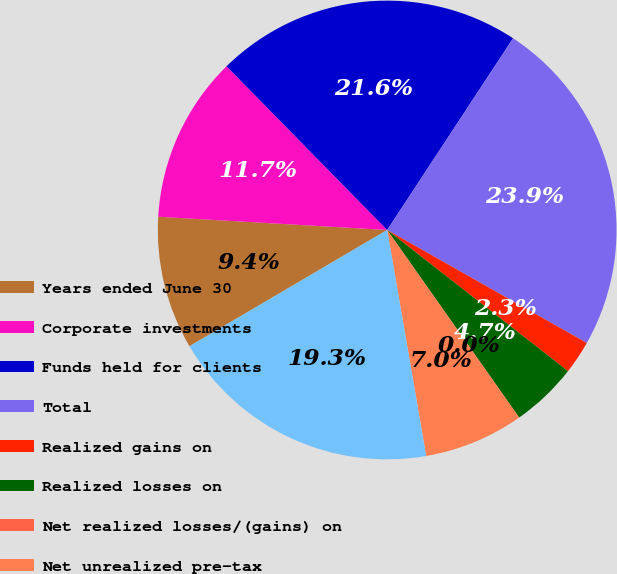Convert chart to OTSL. <chart><loc_0><loc_0><loc_500><loc_500><pie_chart><fcel>Years ended June 30<fcel>Corporate investments<fcel>Funds held for clients<fcel>Total<fcel>Realized gains on<fcel>Realized losses on<fcel>Net realized losses/(gains) on<fcel>Net unrealized pre-tax<fcel>Total available-for-sale<nl><fcel>9.38%<fcel>11.73%<fcel>21.6%<fcel>23.95%<fcel>2.35%<fcel>4.69%<fcel>0.0%<fcel>7.04%<fcel>19.26%<nl></chart> 